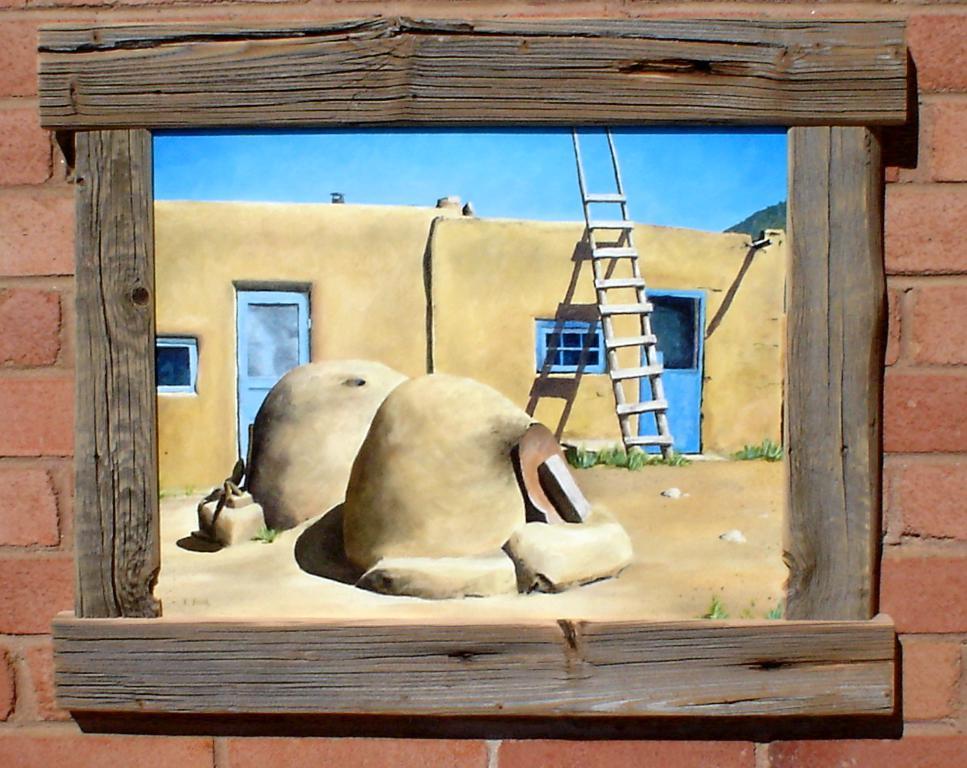Could you give a brief overview of what you see in this image? In this image I can see a frame attached to the wall and the wall is in maroon color, in the frame I can see few stones, a house in brown color, doors and the sky is in blue color. 